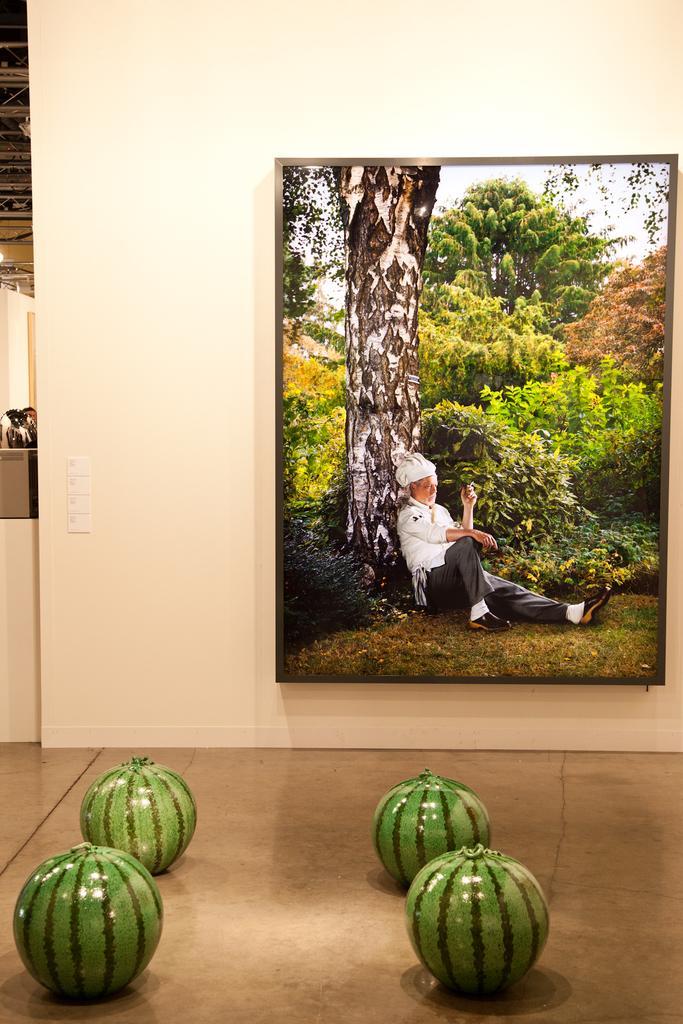Could you give a brief overview of what you see in this image? The picture is taken inside a room where there is a wall on which one big photo is placed and in front the wall there are four big sized watermelons are placed on the floor. 